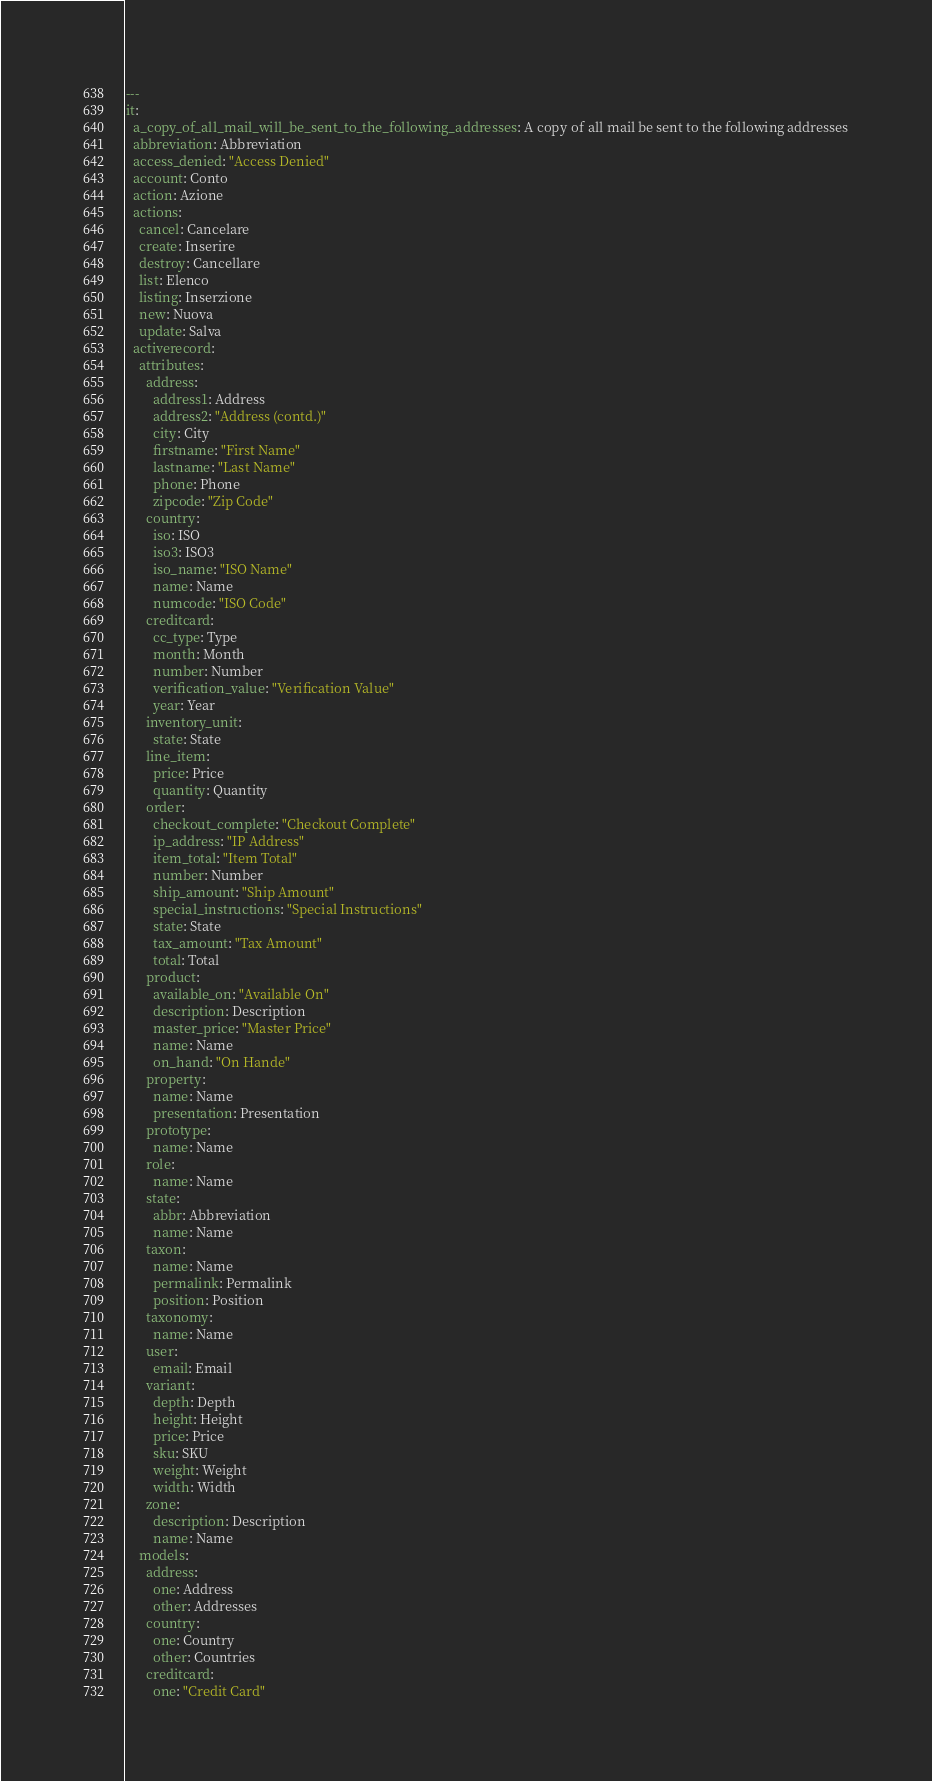Convert code to text. <code><loc_0><loc_0><loc_500><loc_500><_YAML_>--- 
it: 
  a_copy_of_all_mail_will_be_sent_to_the_following_addresses: A copy of all mail be sent to the following addresses
  abbreviation: Abbreviation
  access_denied: "Access Denied"        
  account: Conto
  action: Azione
  actions: 
    cancel: Cancelare
    create: Inserire
    destroy: Cancellare
    list: Elenco
    listing: Inserzione
    new: Nuova
    update: Salva
  activerecord: 
    attributes: 
      address: 
        address1: Address
        address2: "Address (contd.)"
        city: City
        firstname: "First Name"
        lastname: "Last Name"
        phone: Phone
        zipcode: "Zip Code"
      country: 
        iso: ISO
        iso3: ISO3
        iso_name: "ISO Name"
        name: Name
        numcode: "ISO Code"
      creditcard: 
        cc_type: Type
        month: Month
        number: Number
        verification_value: "Verification Value"
        year: Year
      inventory_unit: 
        state: State
      line_item: 
        price: Price
        quantity: Quantity
      order: 
        checkout_complete: "Checkout Complete"
        ip_address: "IP Address"
        item_total: "Item Total"
        number: Number
        ship_amount: "Ship Amount"
        special_instructions: "Special Instructions"
        state: State
        tax_amount: "Tax Amount"
        total: Total
      product: 
        available_on: "Available On"
        description: Description
        master_price: "Master Price"
        name: Name
        on_hand: "On Hande"
      property: 
        name: Name
        presentation: Presentation
      prototype: 
        name: Name
      role: 
        name: Name
      state: 
        abbr: Abbreviation
        name: Name
      taxon: 
        name: Name
        permalink: Permalink
        position: Position
      taxonomy: 
        name: Name
      user: 
        email: Email
      variant: 
        depth: Depth
        height: Height
        price: Price
        sku: SKU
        weight: Weight
        width: Width
      zone: 
        description: Description
        name: Name
    models: 
      address: 
        one: Address
        other: Addresses
      country: 
        one: Country
        other: Countries
      creditcard: 
        one: "Credit Card"</code> 